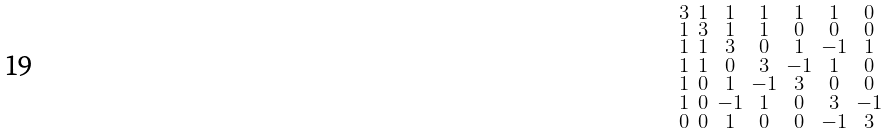Convert formula to latex. <formula><loc_0><loc_0><loc_500><loc_500>\begin{smallmatrix} 3 & 1 & 1 & 1 & 1 & 1 & 0 \\ 1 & 3 & 1 & 1 & 0 & 0 & 0 \\ 1 & 1 & 3 & 0 & 1 & - 1 & 1 \\ 1 & 1 & 0 & 3 & - 1 & 1 & 0 \\ 1 & 0 & 1 & - 1 & 3 & 0 & 0 \\ 1 & 0 & - 1 & 1 & 0 & 3 & - 1 \\ 0 & 0 & 1 & 0 & 0 & - 1 & 3 \end{smallmatrix}</formula> 